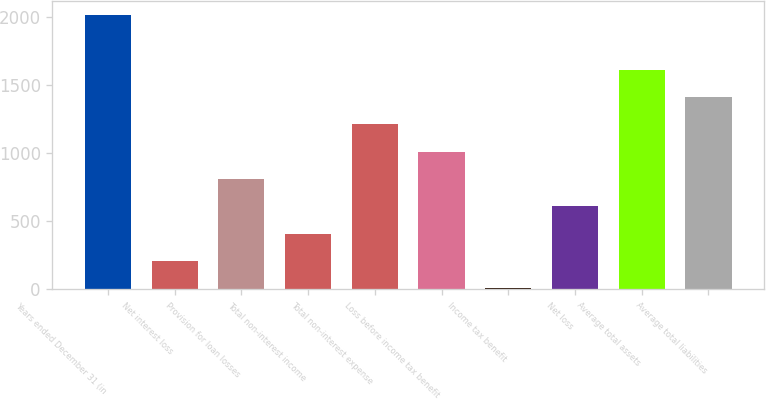Convert chart to OTSL. <chart><loc_0><loc_0><loc_500><loc_500><bar_chart><fcel>Years ended December 31 (in<fcel>Net interest loss<fcel>Provision for loan losses<fcel>Total non-interest income<fcel>Total non-interest expense<fcel>Loss before income tax benefit<fcel>Income tax benefit<fcel>Net loss<fcel>Average total assets<fcel>Average total liabilities<nl><fcel>2013<fcel>207.78<fcel>809.52<fcel>408.36<fcel>1210.68<fcel>1010.1<fcel>7.2<fcel>608.94<fcel>1611.84<fcel>1411.26<nl></chart> 